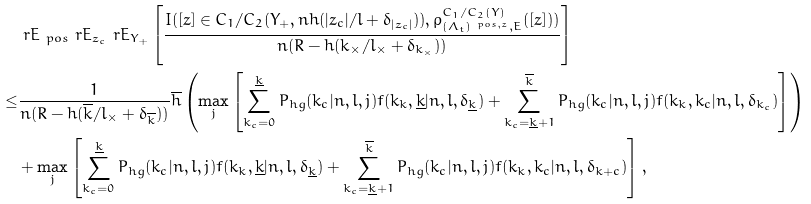Convert formula to latex. <formula><loc_0><loc_0><loc_500><loc_500>& \ r E _ { \ p o s } \ r E _ { z _ { c } } \ r E _ { Y _ { + } } \left [ \frac { I ( [ z ] \in C _ { 1 } / C _ { 2 } ( Y _ { + } , n h ( | z _ { c } | / l + \delta _ { | z _ { c } | } ) ) , \rho _ { ( \Lambda _ { t } ) ^ { \ p o s , z } , E } ^ { C _ { 1 } / C _ { 2 } ( Y ) } ( [ z ] ) ) } { n ( R - h ( k _ { \times } / l _ { \times } + \delta _ { k _ { \times } } ) ) } \right ] \\ \leq & \frac { 1 } { n ( R - h ( \overline { k } / l _ { \times } + \delta _ { \overline { k } } ) ) } \overline { h } \left ( \max _ { j } \left [ \sum _ { k _ { c } = 0 } ^ { \underline { k } } P _ { h g } ( k _ { c } | n , l , j ) f ( k _ { k } , \underline { k } | n , l , \delta _ { \underline { k } } ) + \sum _ { k _ { c } = \underline { k } + 1 } ^ { \overline { k } } P _ { h g } ( k _ { c } | n , l , j ) f ( k _ { k } , k _ { c } | n , l , \delta _ { k _ { c } } ) \right ] \right ) \\ & + \max _ { j } \left [ \sum _ { k _ { c } = 0 } ^ { \underline { k } } P _ { h g } ( k _ { c } | n , l , j ) f ( k _ { k } , \underline { k } | n , l , \delta _ { \underline { k } } ) + \sum _ { k _ { c } = \underline { k } + 1 } ^ { \overline { k } } P _ { h g } ( k _ { c } | n , l , j ) f ( k _ { k } , k _ { c } | n , l , \delta _ { k + c } ) \right ] ,</formula> 